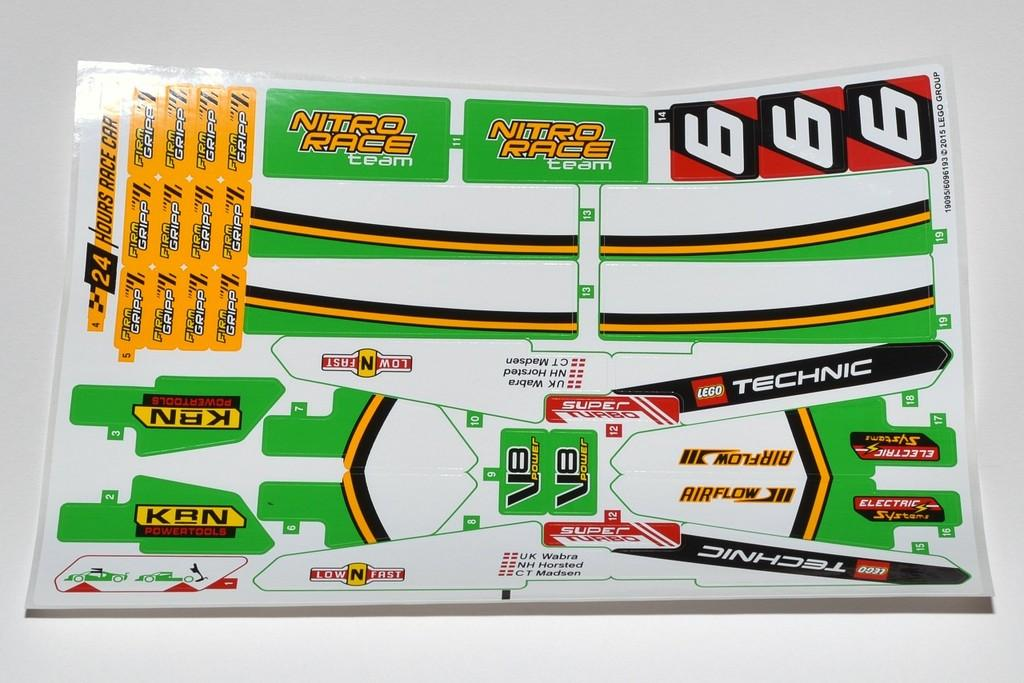<image>
Relay a brief, clear account of the picture shown. stickers for a lego creation including ones that say nitro race 